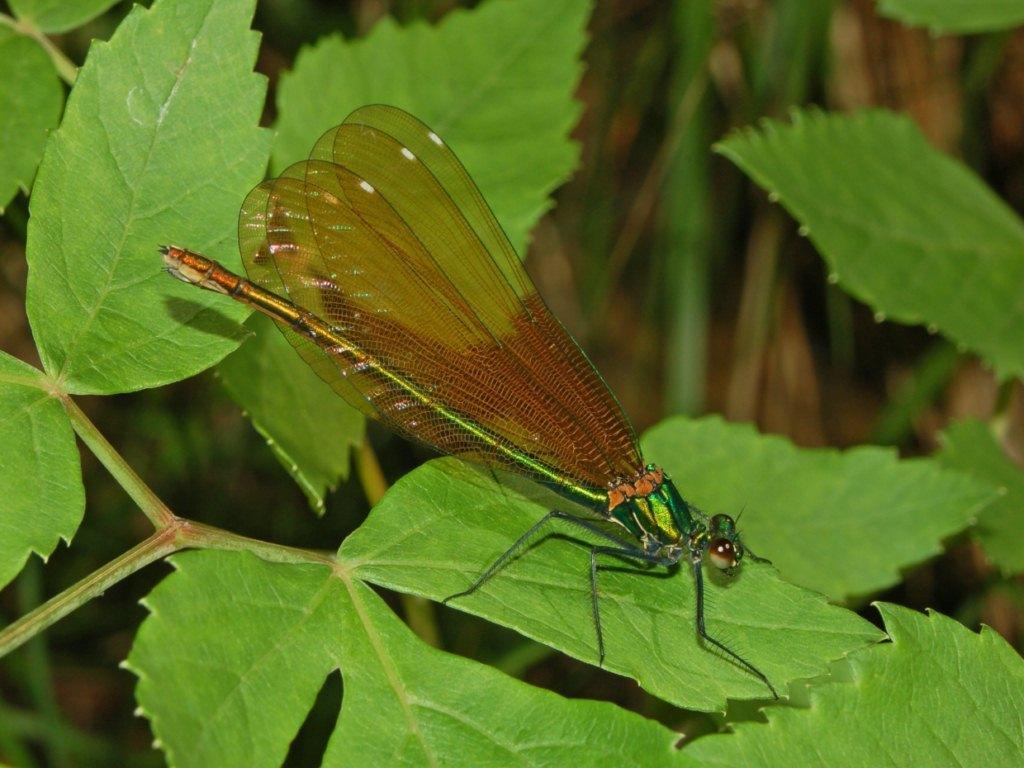Please provide a concise description of this image. This image consists of a dragonfly on the leaf. The leaf are green in color. 